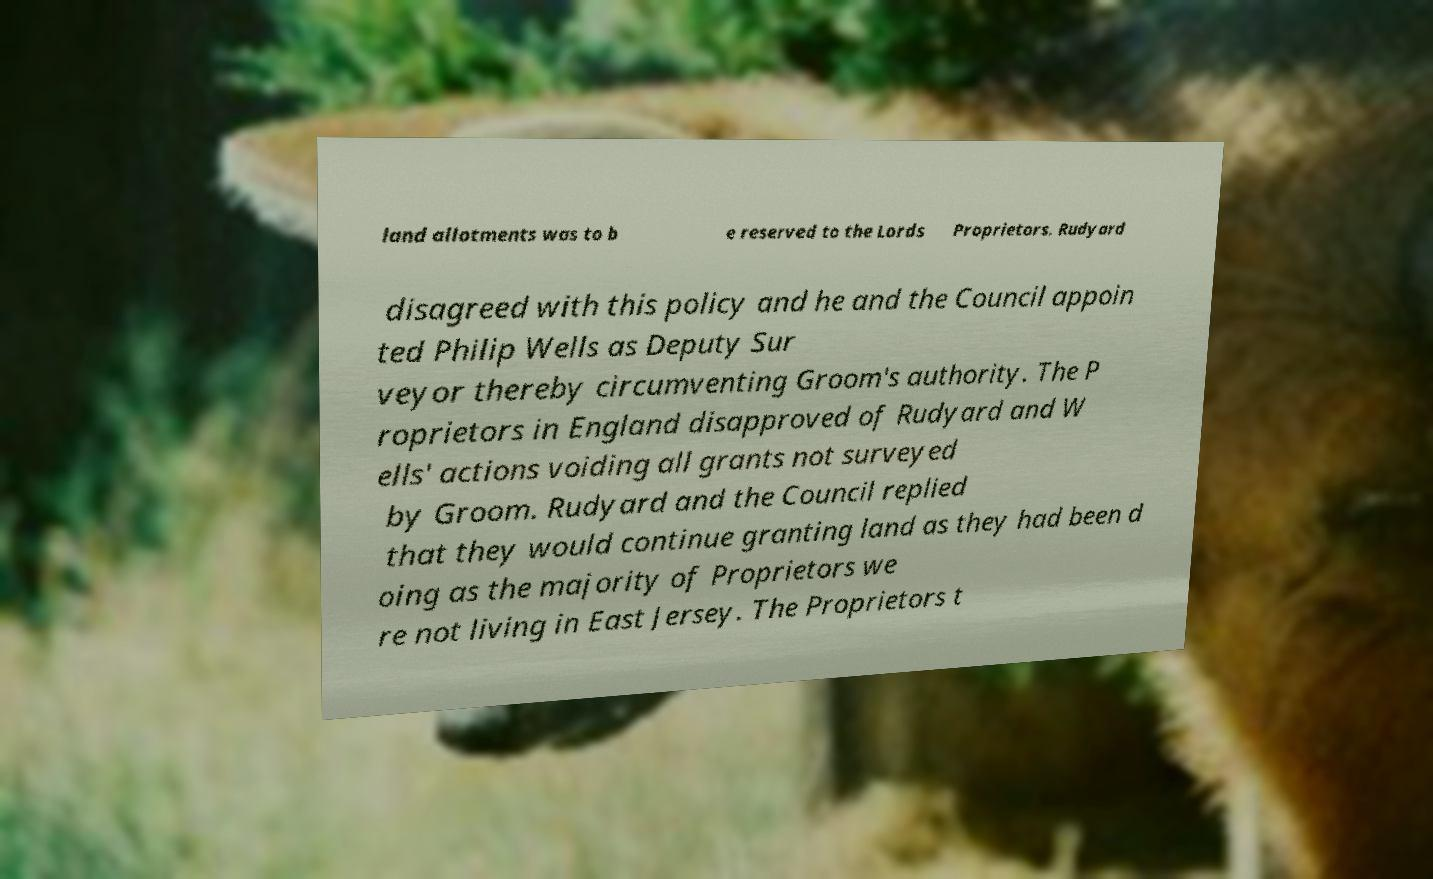Could you extract and type out the text from this image? land allotments was to b e reserved to the Lords Proprietors. Rudyard disagreed with this policy and he and the Council appoin ted Philip Wells as Deputy Sur veyor thereby circumventing Groom's authority. The P roprietors in England disapproved of Rudyard and W ells' actions voiding all grants not surveyed by Groom. Rudyard and the Council replied that they would continue granting land as they had been d oing as the majority of Proprietors we re not living in East Jersey. The Proprietors t 